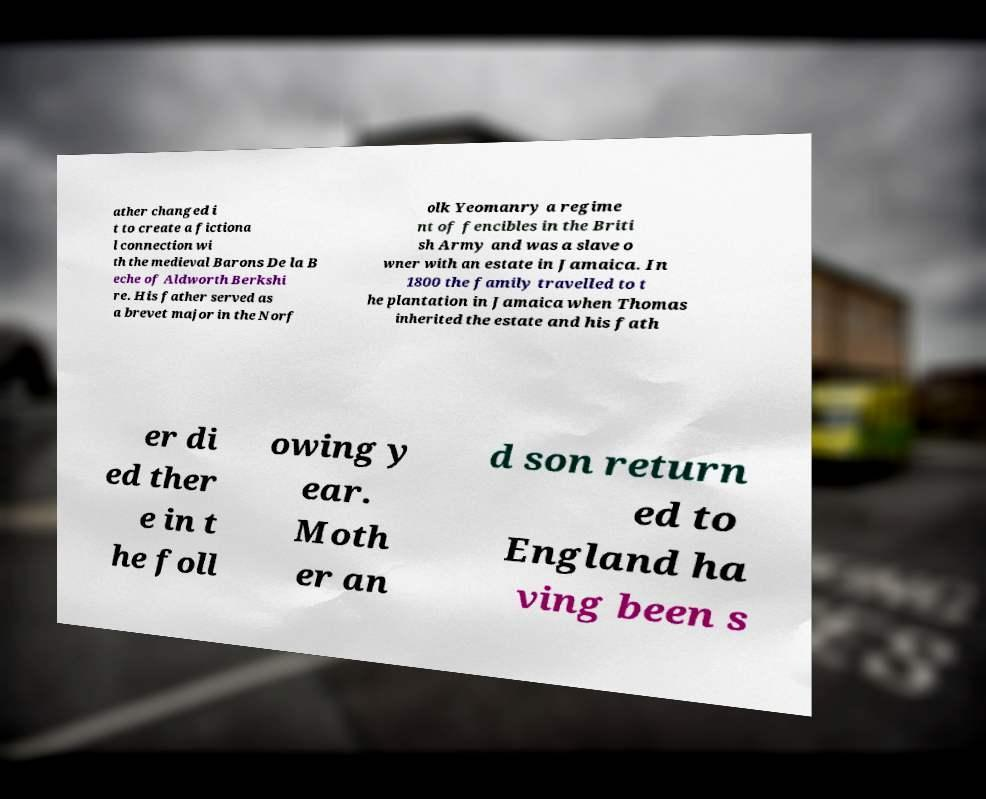Could you extract and type out the text from this image? ather changed i t to create a fictiona l connection wi th the medieval Barons De la B eche of Aldworth Berkshi re. His father served as a brevet major in the Norf olk Yeomanry a regime nt of fencibles in the Briti sh Army and was a slave o wner with an estate in Jamaica. In 1800 the family travelled to t he plantation in Jamaica when Thomas inherited the estate and his fath er di ed ther e in t he foll owing y ear. Moth er an d son return ed to England ha ving been s 